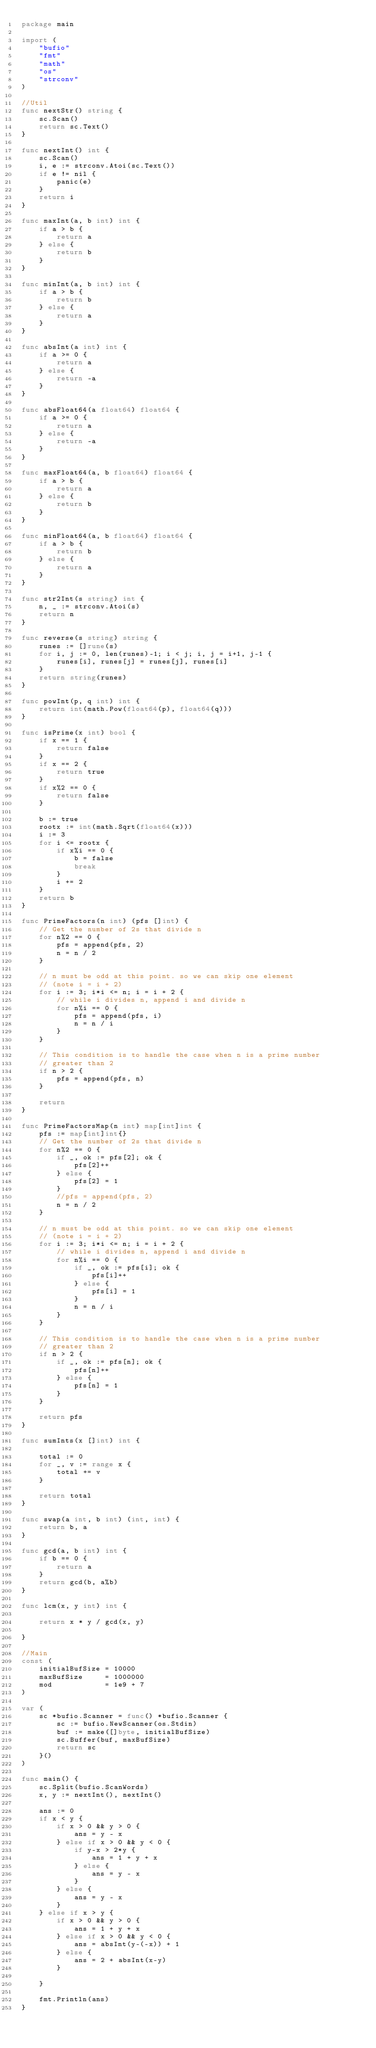Convert code to text. <code><loc_0><loc_0><loc_500><loc_500><_Go_>package main

import (
	"bufio"
	"fmt"
	"math"
	"os"
	"strconv"
)

//Util
func nextStr() string {
	sc.Scan()
	return sc.Text()
}

func nextInt() int {
	sc.Scan()
	i, e := strconv.Atoi(sc.Text())
	if e != nil {
		panic(e)
	}
	return i
}

func maxInt(a, b int) int {
	if a > b {
		return a
	} else {
		return b
	}
}

func minInt(a, b int) int {
	if a > b {
		return b
	} else {
		return a
	}
}

func absInt(a int) int {
	if a >= 0 {
		return a
	} else {
		return -a
	}
}

func absFloat64(a float64) float64 {
	if a >= 0 {
		return a
	} else {
		return -a
	}
}

func maxFloat64(a, b float64) float64 {
	if a > b {
		return a
	} else {
		return b
	}
}

func minFloat64(a, b float64) float64 {
	if a > b {
		return b
	} else {
		return a
	}
}

func str2Int(s string) int {
	n, _ := strconv.Atoi(s)
	return n
}

func reverse(s string) string {
	runes := []rune(s)
	for i, j := 0, len(runes)-1; i < j; i, j = i+1, j-1 {
		runes[i], runes[j] = runes[j], runes[i]
	}
	return string(runes)
}

func powInt(p, q int) int {
	return int(math.Pow(float64(p), float64(q)))
}

func isPrime(x int) bool {
	if x == 1 {
		return false
	}
	if x == 2 {
		return true
	}
	if x%2 == 0 {
		return false
	}

	b := true
	rootx := int(math.Sqrt(float64(x)))
	i := 3
	for i <= rootx {
		if x%i == 0 {
			b = false
			break
		}
		i += 2
	}
	return b
}

func PrimeFactors(n int) (pfs []int) {
	// Get the number of 2s that divide n
	for n%2 == 0 {
		pfs = append(pfs, 2)
		n = n / 2
	}

	// n must be odd at this point. so we can skip one element
	// (note i = i + 2)
	for i := 3; i*i <= n; i = i + 2 {
		// while i divides n, append i and divide n
		for n%i == 0 {
			pfs = append(pfs, i)
			n = n / i
		}
	}

	// This condition is to handle the case when n is a prime number
	// greater than 2
	if n > 2 {
		pfs = append(pfs, n)
	}

	return
}

func PrimeFactorsMap(n int) map[int]int {
	pfs := map[int]int{}
	// Get the number of 2s that divide n
	for n%2 == 0 {
		if _, ok := pfs[2]; ok {
			pfs[2]++
		} else {
			pfs[2] = 1
		}
		//pfs = append(pfs, 2)
		n = n / 2
	}

	// n must be odd at this point. so we can skip one element
	// (note i = i + 2)
	for i := 3; i*i <= n; i = i + 2 {
		// while i divides n, append i and divide n
		for n%i == 0 {
			if _, ok := pfs[i]; ok {
				pfs[i]++
			} else {
				pfs[i] = 1
			}
			n = n / i
		}
	}

	// This condition is to handle the case when n is a prime number
	// greater than 2
	if n > 2 {
		if _, ok := pfs[n]; ok {
			pfs[n]++
		} else {
			pfs[n] = 1
		}
	}

	return pfs
}

func sumInts(x []int) int {

	total := 0
	for _, v := range x {
		total += v
	}

	return total
}

func swap(a int, b int) (int, int) {
	return b, a
}

func gcd(a, b int) int {
	if b == 0 {
		return a
	}
	return gcd(b, a%b)
}

func lcm(x, y int) int {

	return x * y / gcd(x, y)

}

//Main
const (
	initialBufSize = 10000
	maxBufSize     = 1000000
	mod            = 1e9 + 7
)

var (
	sc *bufio.Scanner = func() *bufio.Scanner {
		sc := bufio.NewScanner(os.Stdin)
		buf := make([]byte, initialBufSize)
		sc.Buffer(buf, maxBufSize)
		return sc
	}()
)

func main() {
	sc.Split(bufio.ScanWords)
	x, y := nextInt(), nextInt()

	ans := 0
	if x < y {
		if x > 0 && y > 0 {
			ans = y - x
		} else if x > 0 && y < 0 {
			if y-x > 2*y {
				ans = 1 + y + x
			} else {
				ans = y - x
			}
		} else {
			ans = y - x
		}
	} else if x > y {
		if x > 0 && y > 0 {
			ans = 1 + y + x
		} else if x > 0 && y < 0 {
			ans = absInt(y-(-x)) + 1
		} else {
			ans = 2 + absInt(x-y)
		}

	}

	fmt.Println(ans)
}
</code> 